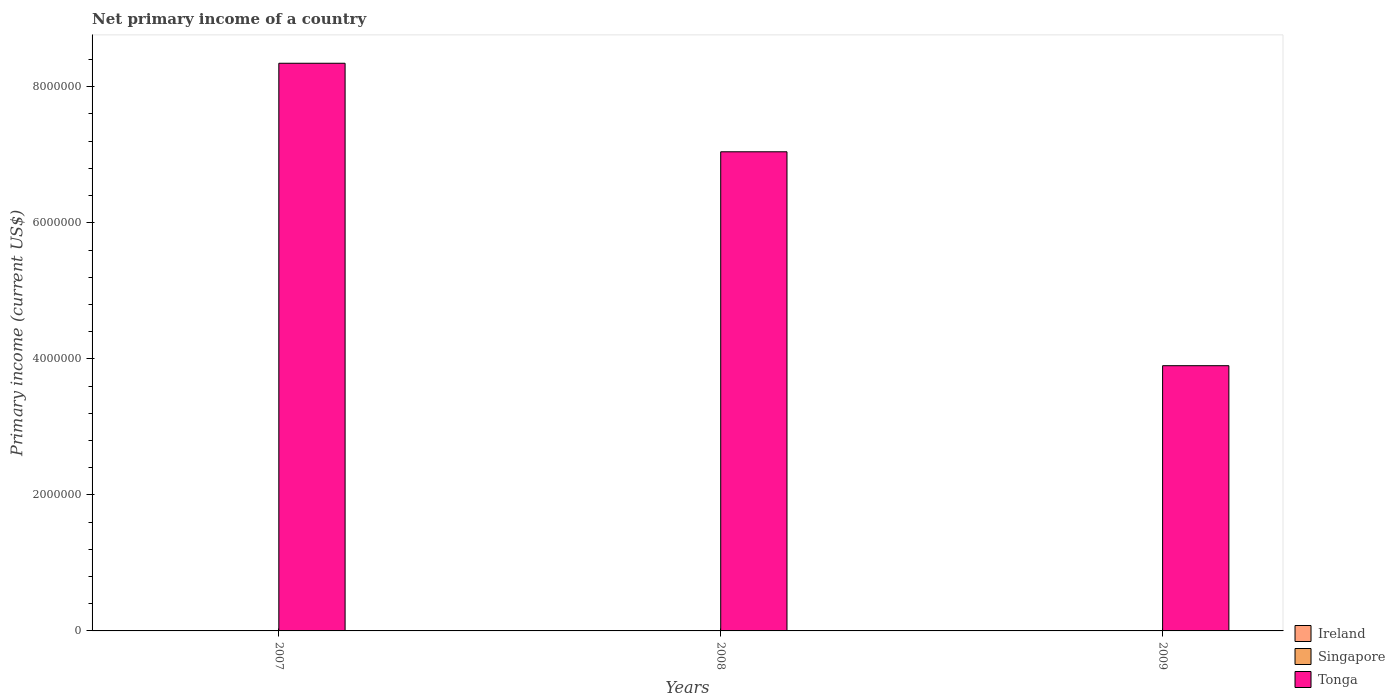How many different coloured bars are there?
Ensure brevity in your answer.  1. Are the number of bars per tick equal to the number of legend labels?
Give a very brief answer. No. How many bars are there on the 1st tick from the left?
Provide a short and direct response. 1. In how many cases, is the number of bars for a given year not equal to the number of legend labels?
Provide a succinct answer. 3. What is the primary income in Ireland in 2009?
Offer a very short reply. 0. Across all years, what is the maximum primary income in Tonga?
Your answer should be very brief. 8.35e+06. Across all years, what is the minimum primary income in Tonga?
Offer a terse response. 3.90e+06. In which year was the primary income in Tonga maximum?
Provide a succinct answer. 2007. What is the total primary income in Ireland in the graph?
Your response must be concise. 0. What is the difference between the primary income in Tonga in 2008 and that in 2009?
Give a very brief answer. 3.14e+06. What is the average primary income in Singapore per year?
Your answer should be compact. 0. What is the ratio of the primary income in Tonga in 2007 to that in 2008?
Your response must be concise. 1.18. Is the primary income in Tonga in 2007 less than that in 2008?
Provide a short and direct response. No. What is the difference between the highest and the second highest primary income in Tonga?
Offer a very short reply. 1.30e+06. What is the difference between the highest and the lowest primary income in Tonga?
Make the answer very short. 4.45e+06. Are all the bars in the graph horizontal?
Your answer should be compact. No. What is the difference between two consecutive major ticks on the Y-axis?
Provide a succinct answer. 2.00e+06. Does the graph contain any zero values?
Your answer should be very brief. Yes. Where does the legend appear in the graph?
Provide a short and direct response. Bottom right. How many legend labels are there?
Provide a short and direct response. 3. What is the title of the graph?
Provide a short and direct response. Net primary income of a country. Does "Guinea-Bissau" appear as one of the legend labels in the graph?
Your answer should be very brief. No. What is the label or title of the Y-axis?
Keep it short and to the point. Primary income (current US$). What is the Primary income (current US$) of Ireland in 2007?
Give a very brief answer. 0. What is the Primary income (current US$) in Singapore in 2007?
Provide a succinct answer. 0. What is the Primary income (current US$) of Tonga in 2007?
Ensure brevity in your answer.  8.35e+06. What is the Primary income (current US$) of Ireland in 2008?
Offer a terse response. 0. What is the Primary income (current US$) of Singapore in 2008?
Your answer should be compact. 0. What is the Primary income (current US$) in Tonga in 2008?
Make the answer very short. 7.04e+06. What is the Primary income (current US$) in Ireland in 2009?
Provide a short and direct response. 0. What is the Primary income (current US$) in Tonga in 2009?
Provide a short and direct response. 3.90e+06. Across all years, what is the maximum Primary income (current US$) in Tonga?
Ensure brevity in your answer.  8.35e+06. Across all years, what is the minimum Primary income (current US$) of Tonga?
Keep it short and to the point. 3.90e+06. What is the total Primary income (current US$) of Ireland in the graph?
Provide a short and direct response. 0. What is the total Primary income (current US$) in Singapore in the graph?
Make the answer very short. 0. What is the total Primary income (current US$) of Tonga in the graph?
Your answer should be compact. 1.93e+07. What is the difference between the Primary income (current US$) in Tonga in 2007 and that in 2008?
Give a very brief answer. 1.30e+06. What is the difference between the Primary income (current US$) in Tonga in 2007 and that in 2009?
Make the answer very short. 4.45e+06. What is the difference between the Primary income (current US$) in Tonga in 2008 and that in 2009?
Ensure brevity in your answer.  3.14e+06. What is the average Primary income (current US$) in Singapore per year?
Make the answer very short. 0. What is the average Primary income (current US$) of Tonga per year?
Offer a terse response. 6.43e+06. What is the ratio of the Primary income (current US$) in Tonga in 2007 to that in 2008?
Offer a very short reply. 1.18. What is the ratio of the Primary income (current US$) of Tonga in 2007 to that in 2009?
Your answer should be compact. 2.14. What is the ratio of the Primary income (current US$) in Tonga in 2008 to that in 2009?
Provide a short and direct response. 1.81. What is the difference between the highest and the second highest Primary income (current US$) of Tonga?
Keep it short and to the point. 1.30e+06. What is the difference between the highest and the lowest Primary income (current US$) in Tonga?
Make the answer very short. 4.45e+06. 